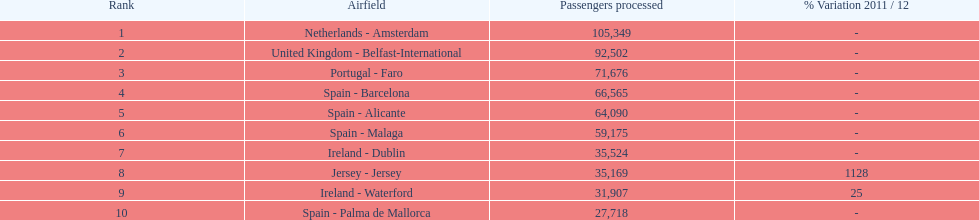Where is the most popular destination for passengers leaving london southend airport? Netherlands - Amsterdam. 